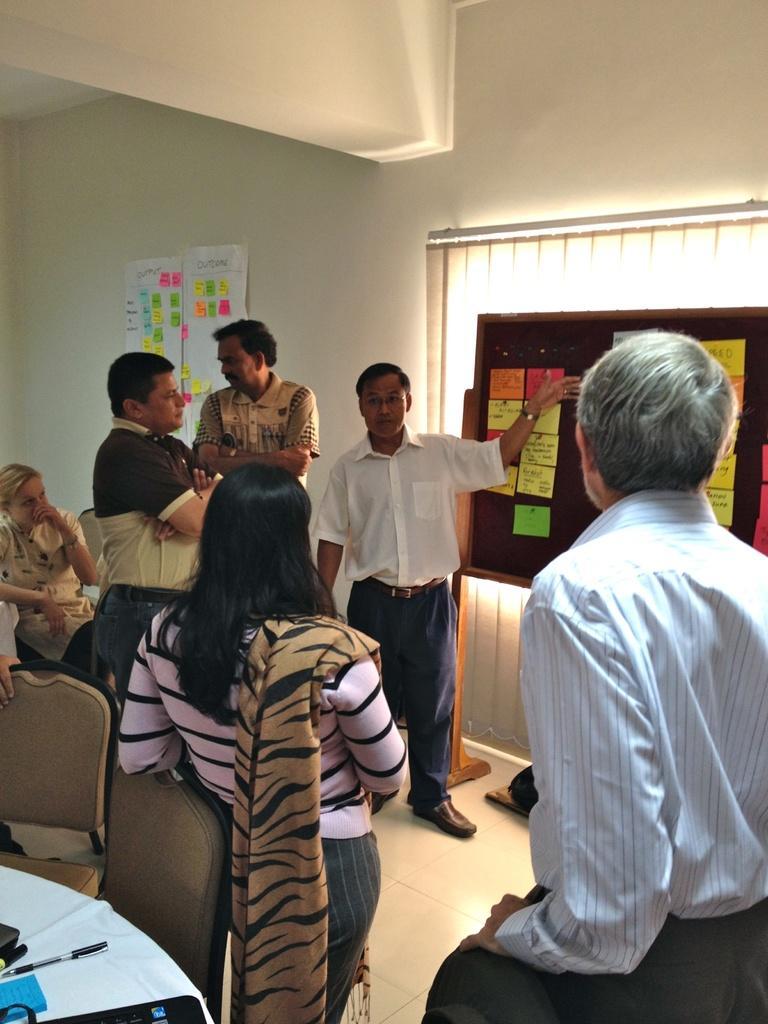Can you describe this image briefly? In this image we can see some peoples standing on the ground. On the left side of the image we can see a woman sitting on a chair some pens, paper and a book placed on the table. On the right side of the image we can see some papers with text on a board and we can also see the window blinds. In the background, we can see some papers pasted on the wall. 